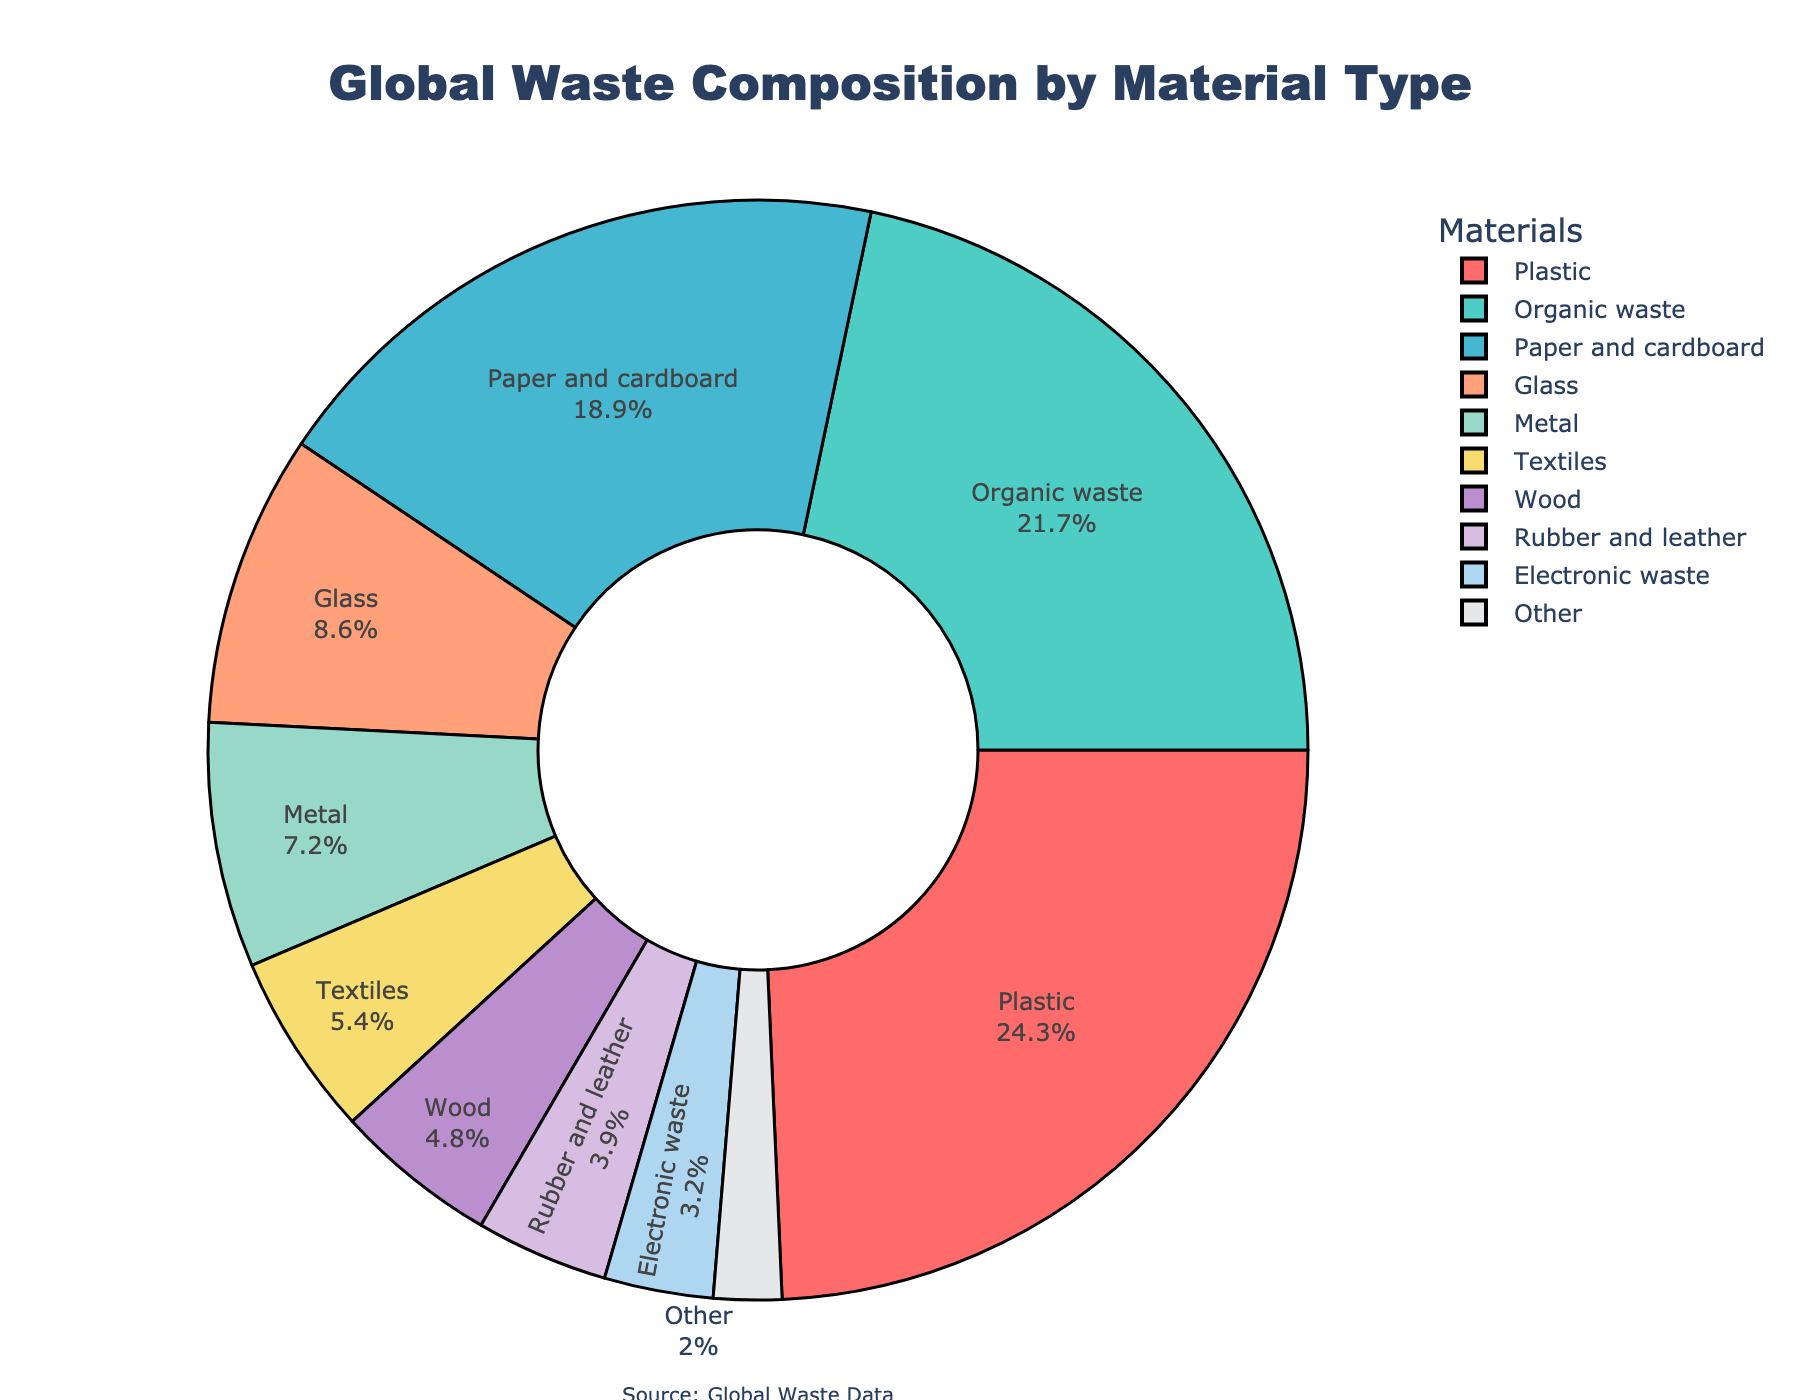What is the most abundant material type in global waste composition? The figure shows a pie chart where the largest segment represents the material type with the highest percentage. Plastics occupy the largest segment.
Answer: Plastic Which material type contributes the least to global waste composition? By inspecting the pie chart, the smallest segment can be identified as the one contributing the least. The segment labeled 'Other' is the smallest.
Answer: Other What are the second and third most common materials in global waste composition? First, we identify the largest segment, which is Plastic (24.3%), and then the next two largest segments. The second largest is Organic waste (21.7%) and the third largest is Paper and cardboard (18.9%).
Answer: Organic waste and Paper and cardboard How much more percentage does Plastic waste contribute compared to Electronic waste? Determine the percentage of Plastic (24.3%) and Electronic waste (3.2%), then subtract the latter from the former: 24.3% - 3.2%.
Answer: 21.1% What is the cumulative percentage of waste for Metal, Textiles, and Rubber and leather? Add the percentages for Metal (7.2%), Textiles (5.4%), and Rubber and leather (3.9%): 7.2% + 5.4% + 3.9%.
Answer: 16.5% Compare the waste contribution of Organic waste and Paper and cardboard. Which one is higher, and by how much? Compare the percentages for Organic waste (21.7%) and Paper and cardboard (18.9%): 21.7% - 18.9%. Organic waste contributes more.
Answer: Organic waste by 2.8% How does the percentage of Glass compare to that of Wood and Rubber and leather combined? Sum the percentages for Wood (4.8%) and Rubber and leather (3.9%) and then compare it to Glass (8.6%): 4.8% + 3.9% = 8.7% and compare 8.7% to 8.6%.
Answer: Almost the same, with Wood and Rubber and leather combined slightly more by 0.1% Which material has an almost equal waste percentage to Glass? Look for the material that has a percentage close to Glass (8.6%). The closest one is Metal with 7.2%, but not equal. Visually, none are precisely equal, but Metal is the nearest.
Answer: None, Metal is closest but not equal What fraction of the global waste is composed of Organic waste and Food waste combined? Summing the provided percentages: Organic waste (21.7%) is directly provided. However, Food waste isn't explicitly mentioned separately, assuming Organic waste includes it.
Answer: 21.7% 